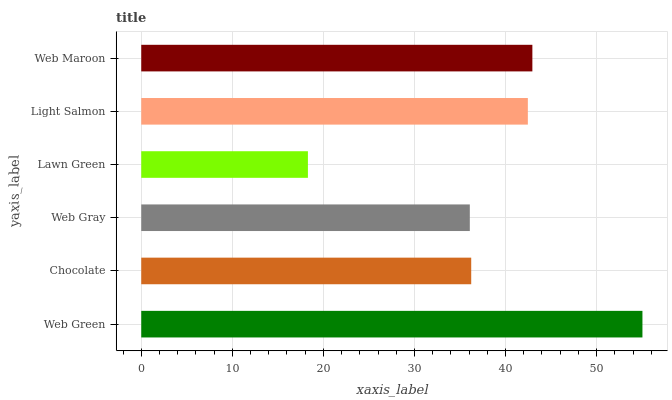Is Lawn Green the minimum?
Answer yes or no. Yes. Is Web Green the maximum?
Answer yes or no. Yes. Is Chocolate the minimum?
Answer yes or no. No. Is Chocolate the maximum?
Answer yes or no. No. Is Web Green greater than Chocolate?
Answer yes or no. Yes. Is Chocolate less than Web Green?
Answer yes or no. Yes. Is Chocolate greater than Web Green?
Answer yes or no. No. Is Web Green less than Chocolate?
Answer yes or no. No. Is Light Salmon the high median?
Answer yes or no. Yes. Is Chocolate the low median?
Answer yes or no. Yes. Is Web Maroon the high median?
Answer yes or no. No. Is Web Maroon the low median?
Answer yes or no. No. 